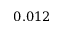Convert formula to latex. <formula><loc_0><loc_0><loc_500><loc_500>0 . 0 1 2</formula> 